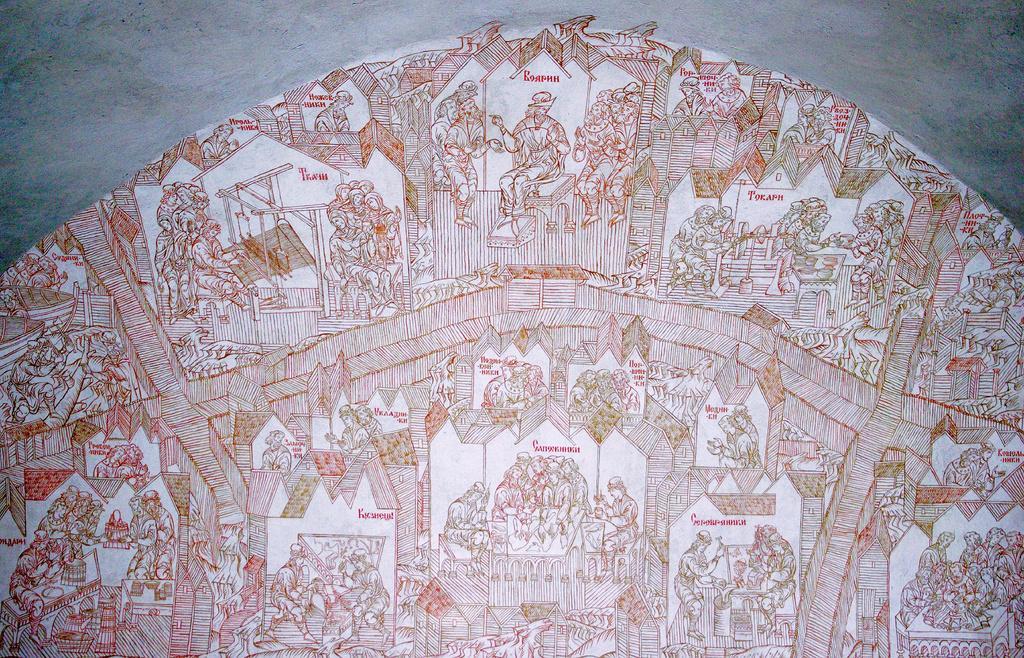Could you give a brief overview of what you see in this image? In this image we can see there are many picture drawn on the wall. 